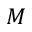Convert formula to latex. <formula><loc_0><loc_0><loc_500><loc_500>M</formula> 